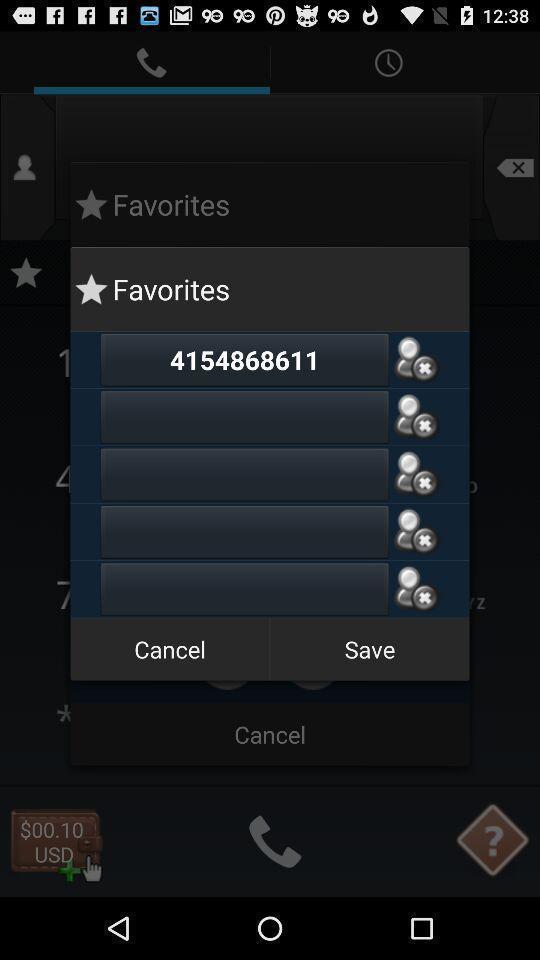Provide a textual representation of this image. Pop-up displaying favorites with other options. 